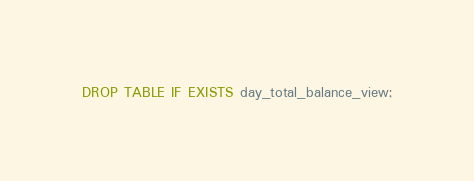Convert code to text. <code><loc_0><loc_0><loc_500><loc_500><_SQL_>DROP TABLE IF EXISTS day_total_balance_view;</code> 